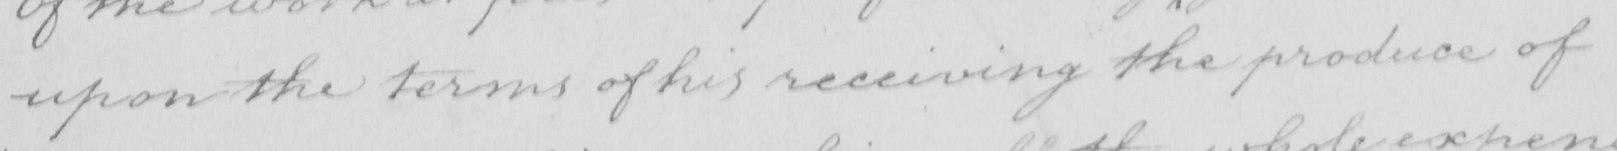What text is written in this handwritten line? upon the terms of his receiving the produce of 